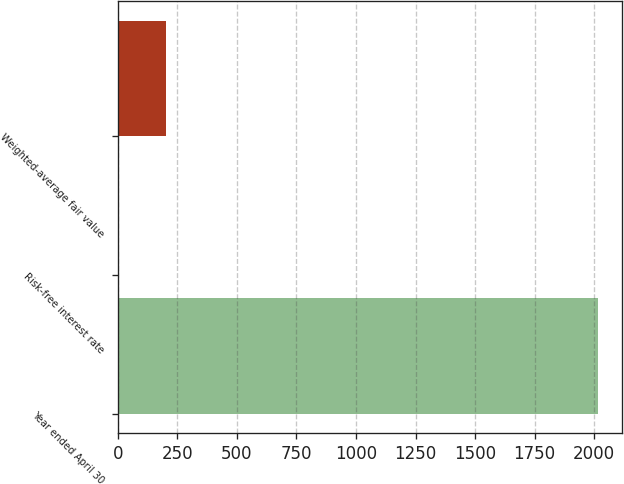Convert chart. <chart><loc_0><loc_0><loc_500><loc_500><bar_chart><fcel>Year ended April 30<fcel>Risk-free interest rate<fcel>Weighted-average fair value<nl><fcel>2014<fcel>0.61<fcel>201.95<nl></chart> 